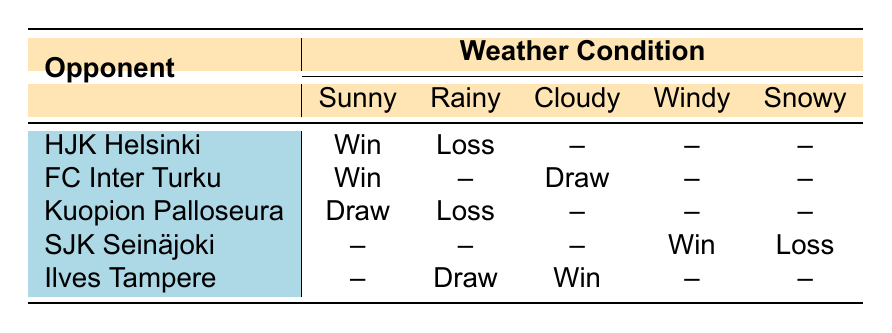What was the outcome of the match against HJK Helsinki on a sunny day? The table shows that the outcome of the match against HJK Helsinki when the weather was sunny is listed under the Sunny column for HJK Helsinki, which is "Win."
Answer: Win How did AC Oulu perform against FC Inter Turku in rainy weather? Looking at the table for FC Inter Turku under the Rainy column, there is no recorded outcome; thus, no match was played in rainy weather against this opponent.
Answer: No match recorded Which opponent resulted in a loss during snowy weather? The table indicates that the only match outcome categorized under Snowy weather is for SJK Seinäjoki, where the outcome was "Loss."
Answer: SJK Seinäjoki What was the total number of wins recorded in the table? By examining the table, the Wins are recorded as follows: against HJK Helsinki (1), FC Inter Turku (1), SJK Seinäjoki (1), and Ilves Tampere (1), which totals to 4 wins.
Answer: 4 Did AC Oulu have any draws against Ilves Tampere? Referring to the table, there is a "Win" recorded against Ilves Tampere in Cloudy weather and a "Draw" in Rainy weather, confirming there were indeed draws against this opponent.
Answer: Yes What is the outcome for Kuopion Palloseura in the sunny weather? The table shows that for Kuopion Palloseura under the Sunny column, the outcome is "Draw."
Answer: Draw Was there a win for AC Oulu against SJK Seinäjoki in rainy conditions? The table has no entry for SJK Seinäjoki in the Rainy column, which means there was no match played in rainy weather resulting in a win for this opponent.
Answer: No Which weather condition resulted in the majority of losses for AC Oulu? Based on the table, losses are recorded under Rainy for HJK Helsinki, Kuopion Palloseura, and Snowy for SJK Seinäjoki. Since three losses occurred during these types of weather, it is a tie between Rainy and Snowy conditions, but Rainy has two entries yielding a higher count.
Answer: Rainy How many opponents did AC Oulu draw against? The table indicates draws against FC Inter Turku (1) and Ilves Tampere (1), resulting in a total of 2 opponents drawn against.
Answer: 2 